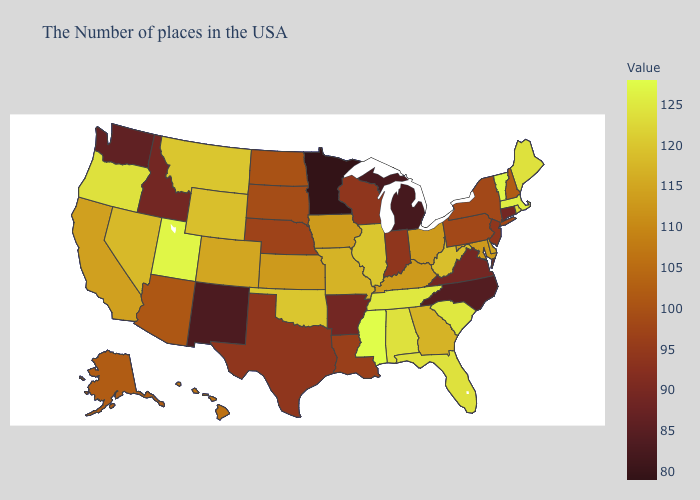Among the states that border South Dakota , which have the highest value?
Give a very brief answer. Montana. Does the map have missing data?
Write a very short answer. No. Is the legend a continuous bar?
Give a very brief answer. Yes. Does the map have missing data?
Keep it brief. No. 